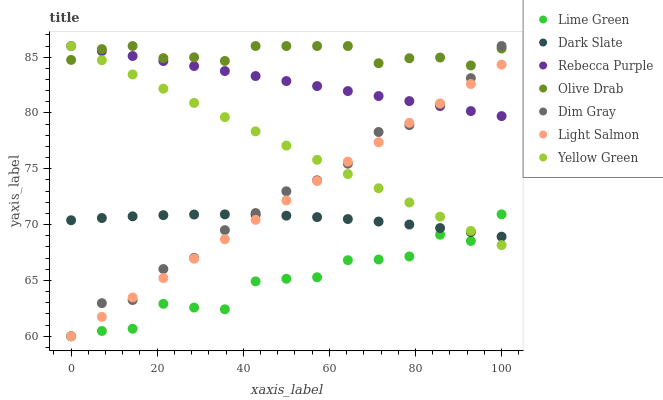Does Lime Green have the minimum area under the curve?
Answer yes or no. Yes. Does Olive Drab have the maximum area under the curve?
Answer yes or no. Yes. Does Dim Gray have the minimum area under the curve?
Answer yes or no. No. Does Dim Gray have the maximum area under the curve?
Answer yes or no. No. Is Rebecca Purple the smoothest?
Answer yes or no. Yes. Is Lime Green the roughest?
Answer yes or no. Yes. Is Dim Gray the smoothest?
Answer yes or no. No. Is Dim Gray the roughest?
Answer yes or no. No. Does Light Salmon have the lowest value?
Answer yes or no. Yes. Does Yellow Green have the lowest value?
Answer yes or no. No. Does Olive Drab have the highest value?
Answer yes or no. Yes. Does Dark Slate have the highest value?
Answer yes or no. No. Is Lime Green less than Rebecca Purple?
Answer yes or no. Yes. Is Rebecca Purple greater than Lime Green?
Answer yes or no. Yes. Does Yellow Green intersect Light Salmon?
Answer yes or no. Yes. Is Yellow Green less than Light Salmon?
Answer yes or no. No. Is Yellow Green greater than Light Salmon?
Answer yes or no. No. Does Lime Green intersect Rebecca Purple?
Answer yes or no. No. 